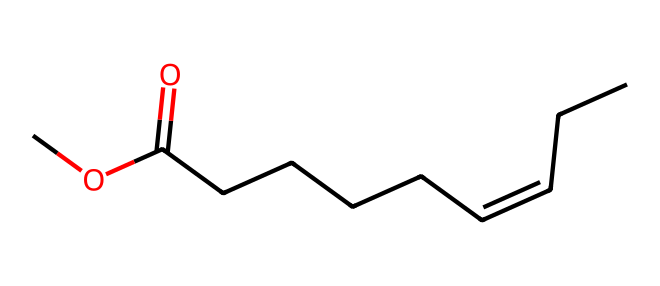What is the main functional group present in this chemical? The chemical structure includes a carboxylate ester functional group, which is indicated by the presence of the carbonyl (C=O) next to an alkoxy (O-C) group.
Answer: ester How many carbon atoms are in the main chain of this molecule? By counting the carbon atoms in the longest continuous carbon chain of the structure, we find there are eight carbon atoms.
Answer: eight What type of isomerism is exhibited by this chemical? The presence of a double bond between the second and third carbon atoms (C=C) indicates that the compound can exhibit geometric isomerism, specifically E-Z isomerism.
Answer: E-Z What is the effect of the geometric isomerism on the physical properties of this chemical? Geometric isomers can have different physical properties, such as boiling points and solubility, due to their different spatial arrangements; thus, E-Z isomerism affects how these molecules interact with their environment.
Answer: different properties How does the E-Z configuration affect the pest control efficacy of this pheromone? The E-Z configuration can influence the biological activity and specificity of the pheromone, as certain isomers may be more effective in attracting target pests, which is critical for sustainable agricultural practices.
Answer: affects efficacy What type of bonding does the double bond in this structure represent? The double bond in the structure consists of one sigma bond and one pi bond, which is characteristic of carbon-carbon double bonds.
Answer: sigma and pi bonds 